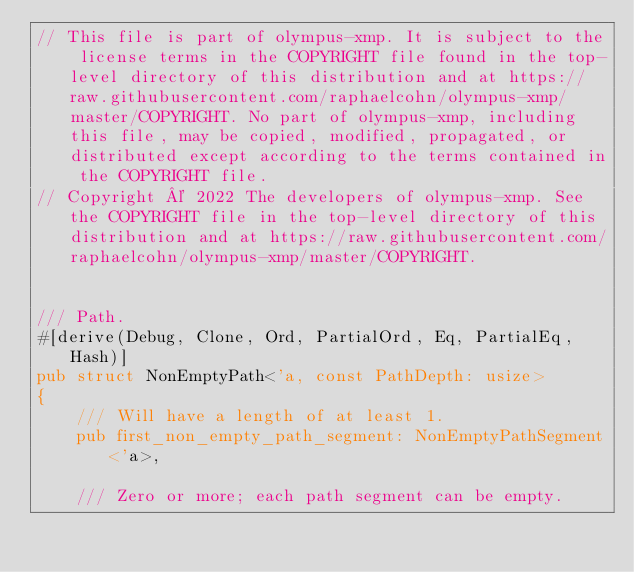Convert code to text. <code><loc_0><loc_0><loc_500><loc_500><_Rust_>// This file is part of olympus-xmp. It is subject to the license terms in the COPYRIGHT file found in the top-level directory of this distribution and at https://raw.githubusercontent.com/raphaelcohn/olympus-xmp/master/COPYRIGHT. No part of olympus-xmp, including this file, may be copied, modified, propagated, or distributed except according to the terms contained in the COPYRIGHT file.
// Copyright © 2022 The developers of olympus-xmp. See the COPYRIGHT file in the top-level directory of this distribution and at https://raw.githubusercontent.com/raphaelcohn/olympus-xmp/master/COPYRIGHT.


/// Path.
#[derive(Debug, Clone, Ord, PartialOrd, Eq, PartialEq, Hash)]
pub struct NonEmptyPath<'a, const PathDepth: usize>
{
	/// Will have a length of at least 1.
	pub first_non_empty_path_segment: NonEmptyPathSegment<'a>,
	
	/// Zero or more; each path segment can be empty.</code> 